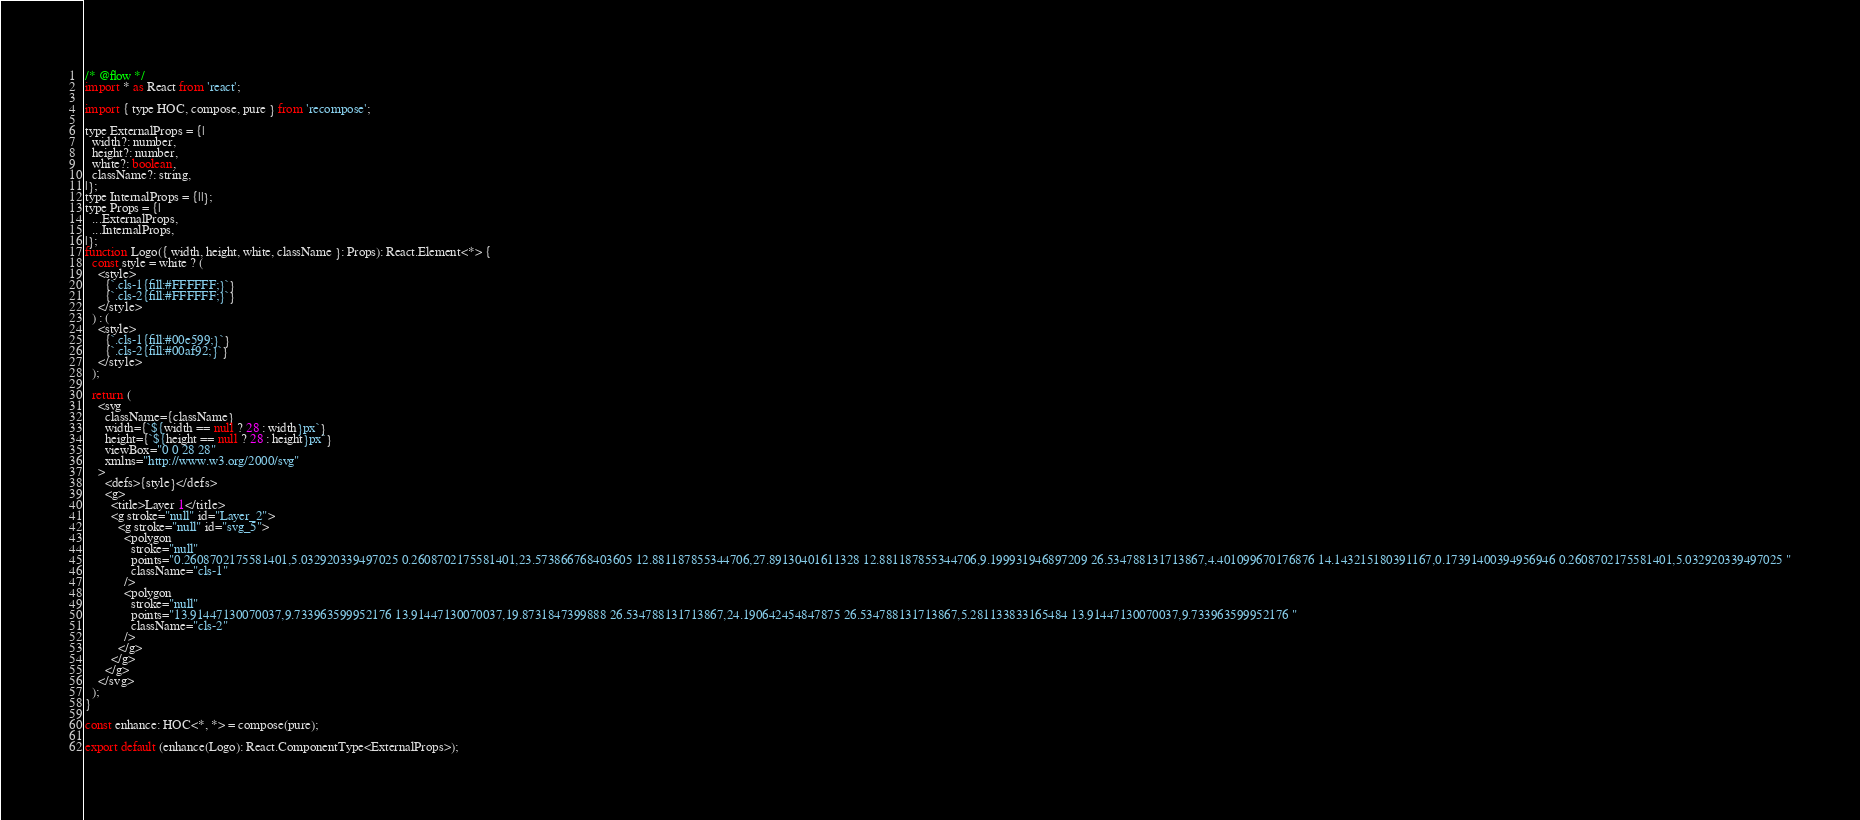<code> <loc_0><loc_0><loc_500><loc_500><_JavaScript_>/* @flow */
import * as React from 'react';

import { type HOC, compose, pure } from 'recompose';

type ExternalProps = {|
  width?: number,
  height?: number,
  white?: boolean,
  className?: string,
|};
type InternalProps = {||};
type Props = {|
  ...ExternalProps,
  ...InternalProps,
|};
function Logo({ width, height, white, className }: Props): React.Element<*> {
  const style = white ? (
    <style>
      {`.cls-1{fill:#FFFFFF;}`}
      {`.cls-2{fill:#FFFFFF;}`}
    </style>
  ) : (
    <style>
      {`.cls-1{fill:#00e599;}`}
      {`.cls-2{fill:#00af92;}`}
    </style>
  );

  return (
    <svg
      className={className}
      width={`${width == null ? 28 : width}px`}
      height={`${height == null ? 28 : height}px`}
      viewBox="0 0 28 28"
      xmlns="http://www.w3.org/2000/svg"
    >
      <defs>{style}</defs>
      <g>
        <title>Layer 1</title>
        <g stroke="null" id="Layer_2">
          <g stroke="null" id="svg_5">
            <polygon
              stroke="null"
              points="0.2608702175581401,5.032920339497025 0.2608702175581401,23.573866768403605 12.881187855344706,27.89130401611328 12.881187855344706,9.199931946897209 26.534788131713867,4.401099670176876 14.143215180391167,0.17391400394956946 0.2608702175581401,5.032920339497025 "
              className="cls-1"
            />
            <polygon
              stroke="null"
              points="13.91447130070037,9.733963599952176 13.91447130070037,19.8731847399888 26.534788131713867,24.190642454847875 26.534788131713867,5.281133833165484 13.91447130070037,9.733963599952176 "
              className="cls-2"
            />
          </g>
        </g>
      </g>
    </svg>
  );
}

const enhance: HOC<*, *> = compose(pure);

export default (enhance(Logo): React.ComponentType<ExternalProps>);
</code> 